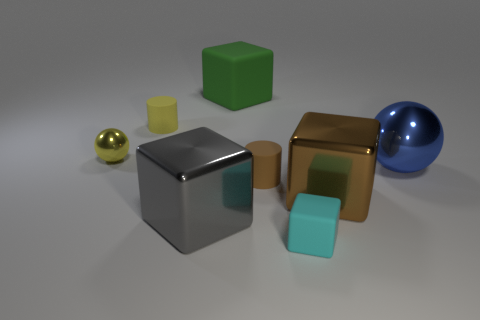Add 1 red rubber cubes. How many objects exist? 9 Subtract all cylinders. How many objects are left? 6 Add 1 cyan objects. How many cyan objects are left? 2 Add 5 gray cubes. How many gray cubes exist? 6 Subtract 0 green cylinders. How many objects are left? 8 Subtract all brown shiny blocks. Subtract all matte objects. How many objects are left? 3 